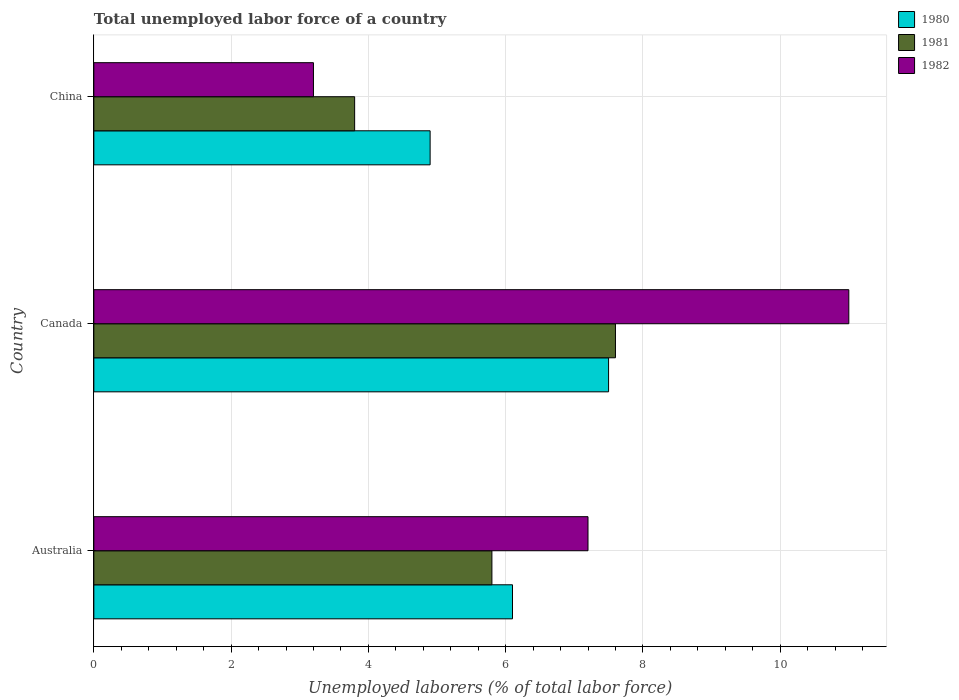How many different coloured bars are there?
Your response must be concise. 3. Are the number of bars per tick equal to the number of legend labels?
Give a very brief answer. Yes. What is the label of the 3rd group of bars from the top?
Your answer should be very brief. Australia. What is the total unemployed labor force in 1981 in Canada?
Your answer should be very brief. 7.6. Across all countries, what is the maximum total unemployed labor force in 1981?
Make the answer very short. 7.6. Across all countries, what is the minimum total unemployed labor force in 1981?
Give a very brief answer. 3.8. In which country was the total unemployed labor force in 1980 maximum?
Offer a terse response. Canada. What is the total total unemployed labor force in 1981 in the graph?
Your answer should be compact. 17.2. What is the difference between the total unemployed labor force in 1982 in Australia and that in Canada?
Offer a very short reply. -3.8. What is the difference between the total unemployed labor force in 1981 in China and the total unemployed labor force in 1982 in Australia?
Provide a succinct answer. -3.4. What is the average total unemployed labor force in 1982 per country?
Offer a terse response. 7.13. What is the difference between the total unemployed labor force in 1981 and total unemployed labor force in 1980 in China?
Provide a short and direct response. -1.1. What is the ratio of the total unemployed labor force in 1981 in Canada to that in China?
Make the answer very short. 2. Is the difference between the total unemployed labor force in 1981 in Australia and China greater than the difference between the total unemployed labor force in 1980 in Australia and China?
Your answer should be very brief. Yes. What is the difference between the highest and the second highest total unemployed labor force in 1981?
Provide a succinct answer. 1.8. What is the difference between the highest and the lowest total unemployed labor force in 1982?
Your response must be concise. 7.8. What does the 3rd bar from the top in Canada represents?
Make the answer very short. 1980. Is it the case that in every country, the sum of the total unemployed labor force in 1982 and total unemployed labor force in 1981 is greater than the total unemployed labor force in 1980?
Make the answer very short. Yes. How many bars are there?
Provide a succinct answer. 9. Are all the bars in the graph horizontal?
Offer a terse response. Yes. What is the difference between two consecutive major ticks on the X-axis?
Make the answer very short. 2. Are the values on the major ticks of X-axis written in scientific E-notation?
Provide a short and direct response. No. Does the graph contain any zero values?
Provide a short and direct response. No. Where does the legend appear in the graph?
Provide a short and direct response. Top right. How are the legend labels stacked?
Make the answer very short. Vertical. What is the title of the graph?
Keep it short and to the point. Total unemployed labor force of a country. Does "1981" appear as one of the legend labels in the graph?
Offer a very short reply. Yes. What is the label or title of the X-axis?
Provide a succinct answer. Unemployed laborers (% of total labor force). What is the Unemployed laborers (% of total labor force) in 1980 in Australia?
Make the answer very short. 6.1. What is the Unemployed laborers (% of total labor force) of 1981 in Australia?
Offer a very short reply. 5.8. What is the Unemployed laborers (% of total labor force) in 1982 in Australia?
Provide a short and direct response. 7.2. What is the Unemployed laborers (% of total labor force) of 1980 in Canada?
Provide a succinct answer. 7.5. What is the Unemployed laborers (% of total labor force) in 1981 in Canada?
Your response must be concise. 7.6. What is the Unemployed laborers (% of total labor force) in 1980 in China?
Make the answer very short. 4.9. What is the Unemployed laborers (% of total labor force) of 1981 in China?
Your answer should be compact. 3.8. What is the Unemployed laborers (% of total labor force) in 1982 in China?
Your answer should be very brief. 3.2. Across all countries, what is the maximum Unemployed laborers (% of total labor force) in 1981?
Provide a succinct answer. 7.6. Across all countries, what is the maximum Unemployed laborers (% of total labor force) in 1982?
Provide a short and direct response. 11. Across all countries, what is the minimum Unemployed laborers (% of total labor force) of 1980?
Your answer should be very brief. 4.9. Across all countries, what is the minimum Unemployed laborers (% of total labor force) of 1981?
Your answer should be very brief. 3.8. Across all countries, what is the minimum Unemployed laborers (% of total labor force) in 1982?
Keep it short and to the point. 3.2. What is the total Unemployed laborers (% of total labor force) in 1980 in the graph?
Your answer should be compact. 18.5. What is the total Unemployed laborers (% of total labor force) of 1982 in the graph?
Offer a terse response. 21.4. What is the difference between the Unemployed laborers (% of total labor force) in 1981 in Australia and that in Canada?
Your answer should be compact. -1.8. What is the difference between the Unemployed laborers (% of total labor force) in 1980 in Australia and that in China?
Offer a terse response. 1.2. What is the difference between the Unemployed laborers (% of total labor force) in 1981 in Australia and that in China?
Your answer should be compact. 2. What is the difference between the Unemployed laborers (% of total labor force) in 1982 in Australia and that in China?
Your answer should be compact. 4. What is the difference between the Unemployed laborers (% of total labor force) in 1980 in Canada and that in China?
Make the answer very short. 2.6. What is the difference between the Unemployed laborers (% of total labor force) of 1981 in Canada and that in China?
Keep it short and to the point. 3.8. What is the difference between the Unemployed laborers (% of total labor force) of 1982 in Canada and that in China?
Your answer should be very brief. 7.8. What is the difference between the Unemployed laborers (% of total labor force) of 1980 in Australia and the Unemployed laborers (% of total labor force) of 1981 in Canada?
Provide a short and direct response. -1.5. What is the difference between the Unemployed laborers (% of total labor force) in 1981 in Australia and the Unemployed laborers (% of total labor force) in 1982 in Canada?
Keep it short and to the point. -5.2. What is the difference between the Unemployed laborers (% of total labor force) in 1980 in Australia and the Unemployed laborers (% of total labor force) in 1981 in China?
Ensure brevity in your answer.  2.3. What is the difference between the Unemployed laborers (% of total labor force) in 1981 in Australia and the Unemployed laborers (% of total labor force) in 1982 in China?
Offer a very short reply. 2.6. What is the difference between the Unemployed laborers (% of total labor force) of 1980 in Canada and the Unemployed laborers (% of total labor force) of 1981 in China?
Your response must be concise. 3.7. What is the difference between the Unemployed laborers (% of total labor force) in 1981 in Canada and the Unemployed laborers (% of total labor force) in 1982 in China?
Your answer should be very brief. 4.4. What is the average Unemployed laborers (% of total labor force) of 1980 per country?
Ensure brevity in your answer.  6.17. What is the average Unemployed laborers (% of total labor force) in 1981 per country?
Provide a short and direct response. 5.73. What is the average Unemployed laborers (% of total labor force) in 1982 per country?
Your answer should be very brief. 7.13. What is the difference between the Unemployed laborers (% of total labor force) of 1980 and Unemployed laborers (% of total labor force) of 1982 in Australia?
Give a very brief answer. -1.1. What is the difference between the Unemployed laborers (% of total labor force) of 1981 and Unemployed laborers (% of total labor force) of 1982 in Australia?
Your answer should be compact. -1.4. What is the difference between the Unemployed laborers (% of total labor force) of 1980 and Unemployed laborers (% of total labor force) of 1981 in Canada?
Make the answer very short. -0.1. What is the difference between the Unemployed laborers (% of total labor force) in 1980 and Unemployed laborers (% of total labor force) in 1981 in China?
Provide a succinct answer. 1.1. What is the ratio of the Unemployed laborers (% of total labor force) of 1980 in Australia to that in Canada?
Ensure brevity in your answer.  0.81. What is the ratio of the Unemployed laborers (% of total labor force) in 1981 in Australia to that in Canada?
Offer a terse response. 0.76. What is the ratio of the Unemployed laborers (% of total labor force) of 1982 in Australia to that in Canada?
Give a very brief answer. 0.65. What is the ratio of the Unemployed laborers (% of total labor force) in 1980 in Australia to that in China?
Offer a terse response. 1.24. What is the ratio of the Unemployed laborers (% of total labor force) in 1981 in Australia to that in China?
Provide a short and direct response. 1.53. What is the ratio of the Unemployed laborers (% of total labor force) of 1982 in Australia to that in China?
Your answer should be very brief. 2.25. What is the ratio of the Unemployed laborers (% of total labor force) of 1980 in Canada to that in China?
Ensure brevity in your answer.  1.53. What is the ratio of the Unemployed laborers (% of total labor force) of 1981 in Canada to that in China?
Your response must be concise. 2. What is the ratio of the Unemployed laborers (% of total labor force) in 1982 in Canada to that in China?
Your answer should be compact. 3.44. What is the difference between the highest and the second highest Unemployed laborers (% of total labor force) in 1980?
Offer a very short reply. 1.4. What is the difference between the highest and the lowest Unemployed laborers (% of total labor force) of 1980?
Your answer should be very brief. 2.6. 